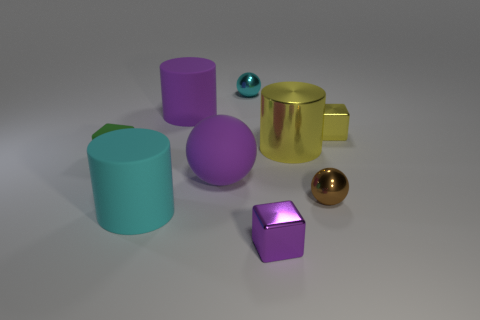Subtract all blocks. How many objects are left? 6 Add 8 large purple rubber cubes. How many large purple rubber cubes exist? 8 Subtract 1 cyan spheres. How many objects are left? 8 Subtract all red balls. Subtract all tiny brown spheres. How many objects are left? 8 Add 5 cyan things. How many cyan things are left? 7 